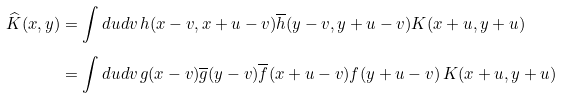<formula> <loc_0><loc_0><loc_500><loc_500>\widehat { K } ( x , y ) & = \int d u d v \, h ( x - v , x + u - v ) \overline { h } ( y - v , y + u - v ) K ( x + u , y + u ) \\ & = \int d u d v \, g ( x - v ) \overline { g } ( y - v ) \overline { f } ( x + u - v ) f ( y + u - v ) \, K ( x + u , y + u )</formula> 